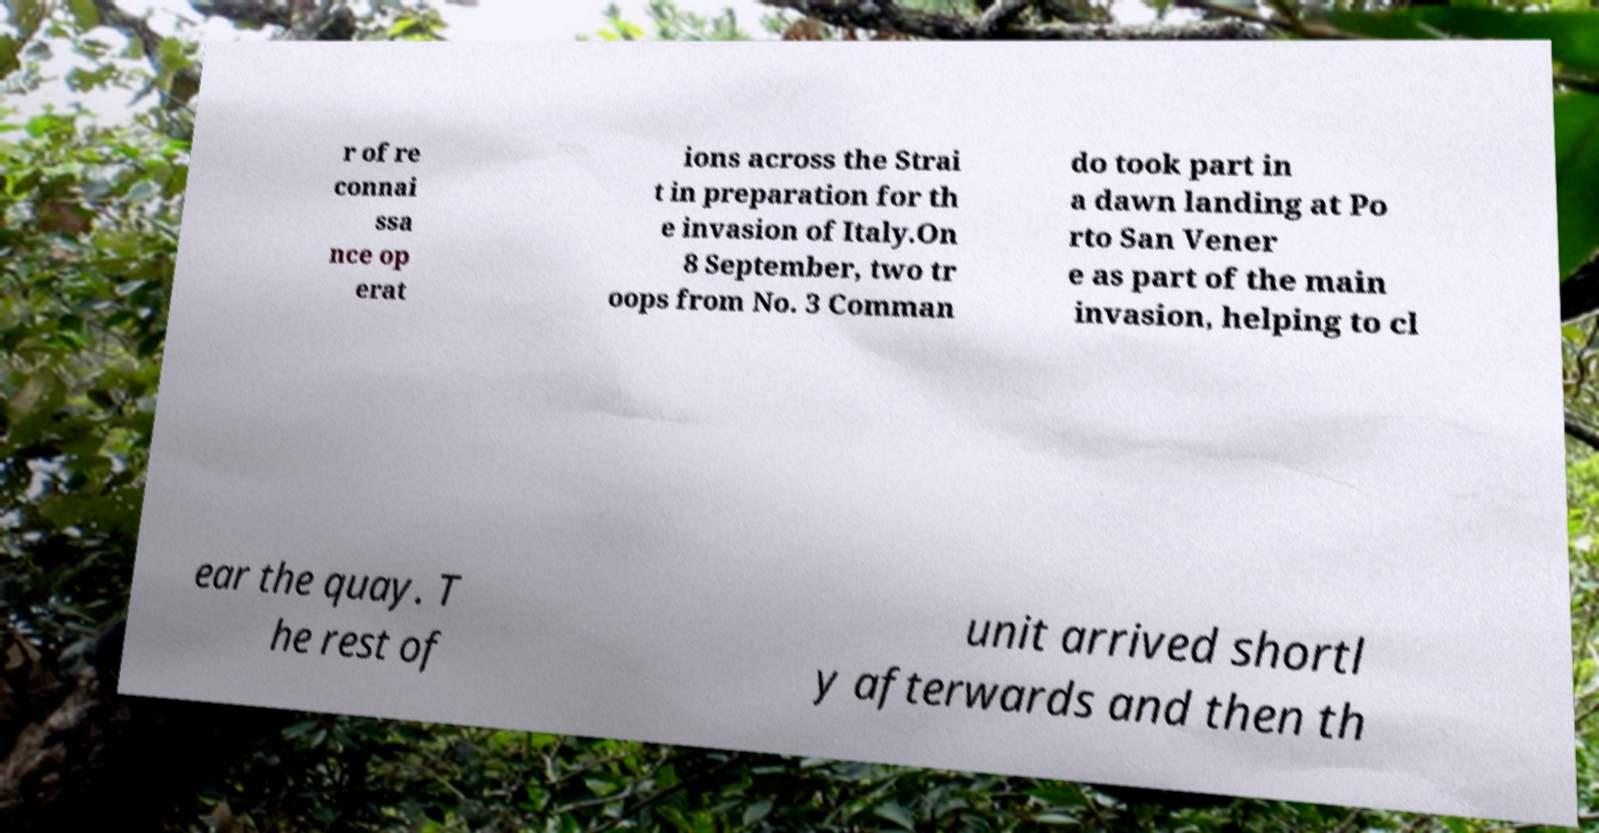I need the written content from this picture converted into text. Can you do that? r of re connai ssa nce op erat ions across the Strai t in preparation for th e invasion of Italy.On 8 September, two tr oops from No. 3 Comman do took part in a dawn landing at Po rto San Vener e as part of the main invasion, helping to cl ear the quay. T he rest of unit arrived shortl y afterwards and then th 